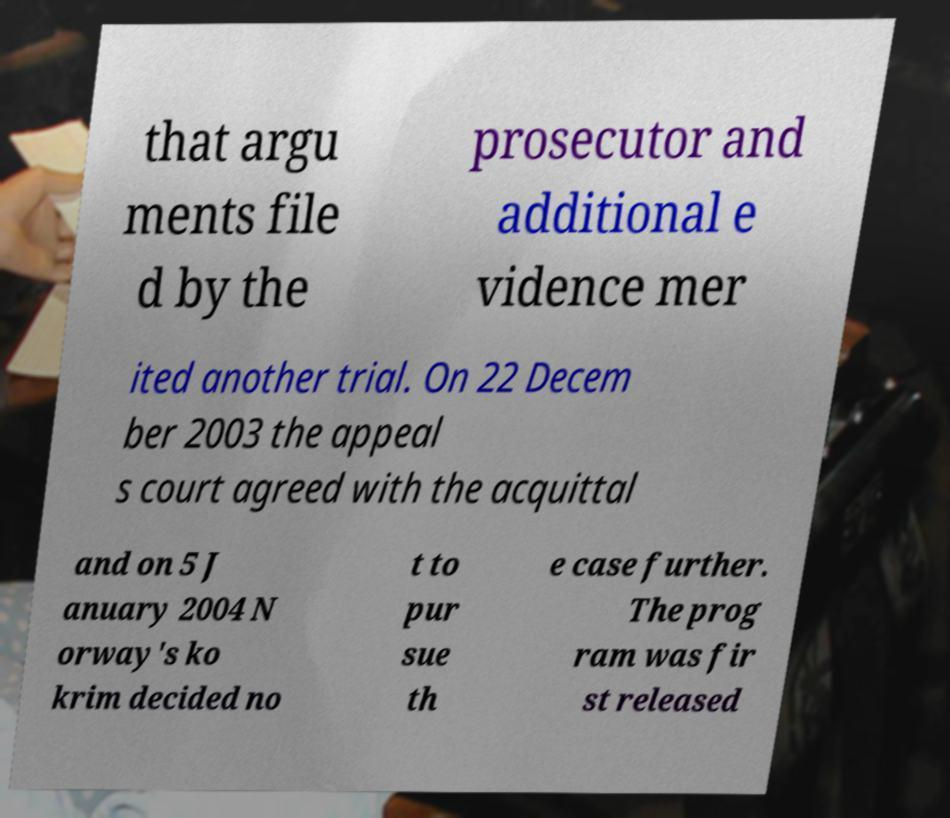What messages or text are displayed in this image? I need them in a readable, typed format. that argu ments file d by the prosecutor and additional e vidence mer ited another trial. On 22 Decem ber 2003 the appeal s court agreed with the acquittal and on 5 J anuary 2004 N orway's ko krim decided no t to pur sue th e case further. The prog ram was fir st released 